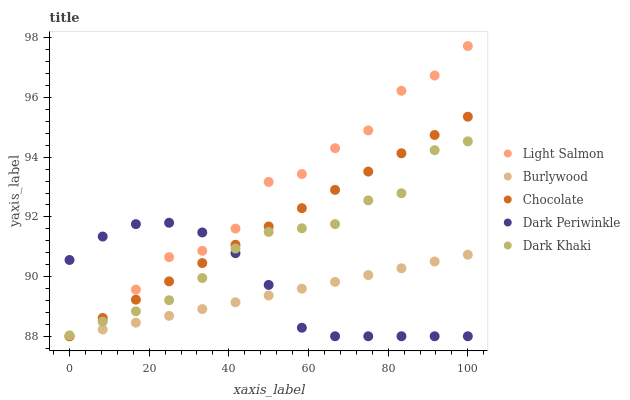Does Burlywood have the minimum area under the curve?
Answer yes or no. Yes. Does Light Salmon have the maximum area under the curve?
Answer yes or no. Yes. Does Dark Khaki have the minimum area under the curve?
Answer yes or no. No. Does Dark Khaki have the maximum area under the curve?
Answer yes or no. No. Is Chocolate the smoothest?
Answer yes or no. Yes. Is Light Salmon the roughest?
Answer yes or no. Yes. Is Dark Khaki the smoothest?
Answer yes or no. No. Is Dark Khaki the roughest?
Answer yes or no. No. Does Burlywood have the lowest value?
Answer yes or no. Yes. Does Dark Khaki have the lowest value?
Answer yes or no. No. Does Light Salmon have the highest value?
Answer yes or no. Yes. Does Dark Khaki have the highest value?
Answer yes or no. No. Is Burlywood less than Dark Khaki?
Answer yes or no. Yes. Is Dark Khaki greater than Burlywood?
Answer yes or no. Yes. Does Dark Khaki intersect Light Salmon?
Answer yes or no. Yes. Is Dark Khaki less than Light Salmon?
Answer yes or no. No. Is Dark Khaki greater than Light Salmon?
Answer yes or no. No. Does Burlywood intersect Dark Khaki?
Answer yes or no. No. 